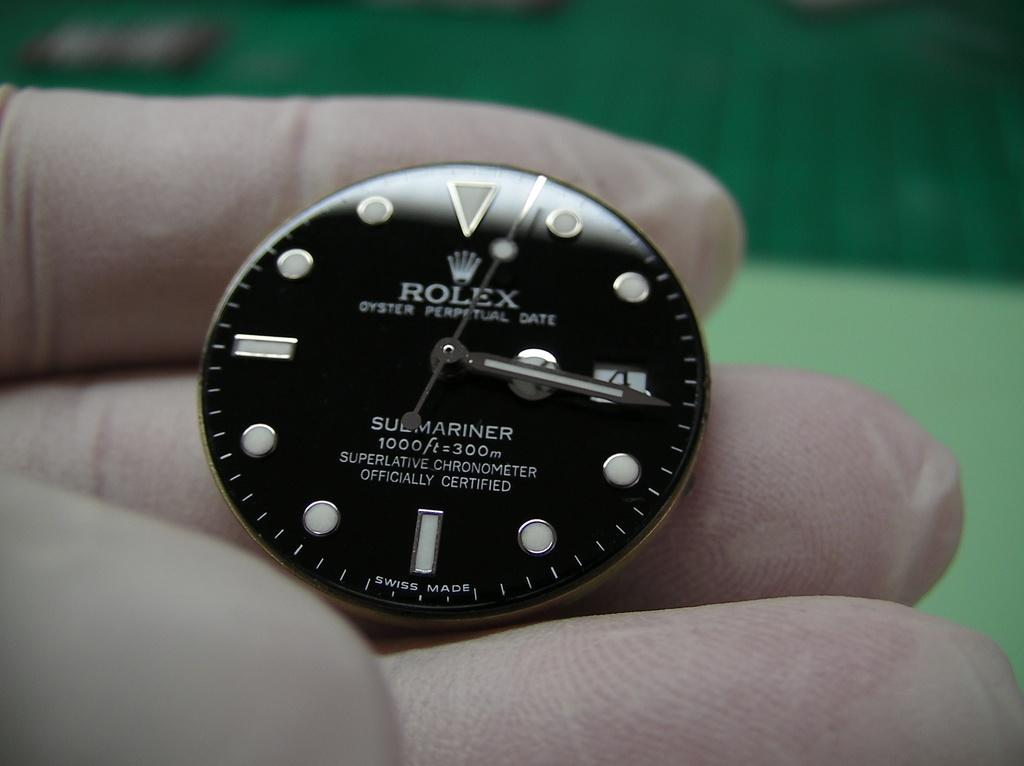<image>
Present a compact description of the photo's key features. A watch face by Rolex is being held in someone's hand. 